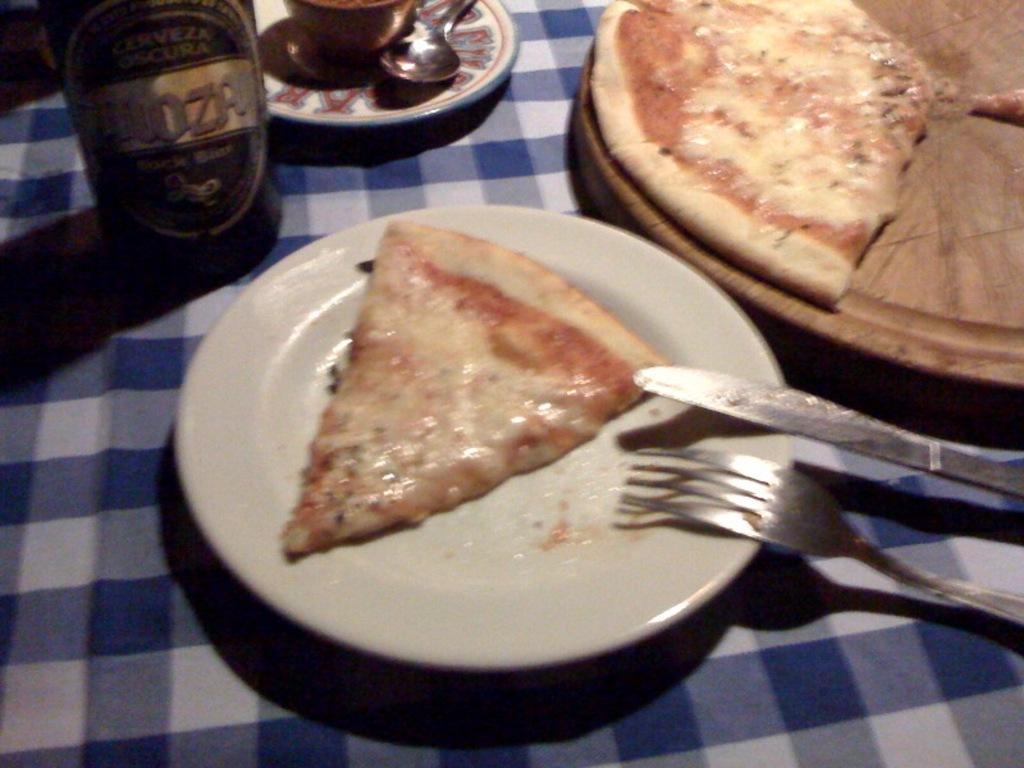Please provide a concise description of this image. In the picture there is a pizza slice kept on the plate and beside that there is a knife and a fork. Beside the plate on a wooden plate there are two Pizza slices and in the left side there is a bottle and beside that there is a cup and a saucer. 